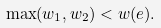Convert formula to latex. <formula><loc_0><loc_0><loc_500><loc_500>\max ( w _ { 1 } , w _ { 2 } ) < w ( e ) .</formula> 